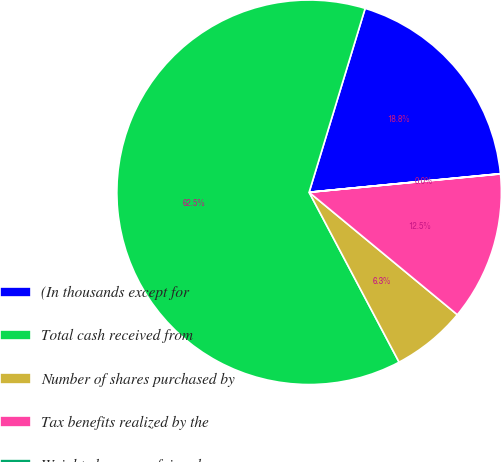<chart> <loc_0><loc_0><loc_500><loc_500><pie_chart><fcel>(In thousands except for<fcel>Total cash received from<fcel>Number of shares purchased by<fcel>Tax benefits realized by the<fcel>Weighted-average fair value<nl><fcel>18.75%<fcel>62.46%<fcel>6.26%<fcel>12.51%<fcel>0.02%<nl></chart> 